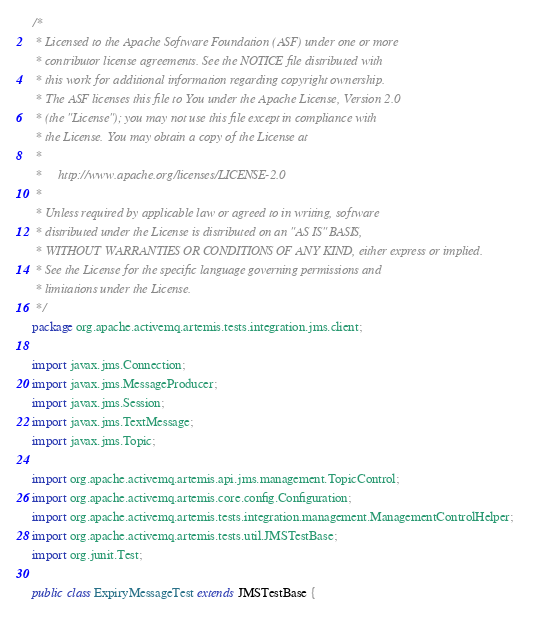Convert code to text. <code><loc_0><loc_0><loc_500><loc_500><_Java_>/*
 * Licensed to the Apache Software Foundation (ASF) under one or more
 * contributor license agreements. See the NOTICE file distributed with
 * this work for additional information regarding copyright ownership.
 * The ASF licenses this file to You under the Apache License, Version 2.0
 * (the "License"); you may not use this file except in compliance with
 * the License. You may obtain a copy of the License at
 *
 *     http://www.apache.org/licenses/LICENSE-2.0
 *
 * Unless required by applicable law or agreed to in writing, software
 * distributed under the License is distributed on an "AS IS" BASIS,
 * WITHOUT WARRANTIES OR CONDITIONS OF ANY KIND, either express or implied.
 * See the License for the specific language governing permissions and
 * limitations under the License.
 */
package org.apache.activemq.artemis.tests.integration.jms.client;

import javax.jms.Connection;
import javax.jms.MessageProducer;
import javax.jms.Session;
import javax.jms.TextMessage;
import javax.jms.Topic;

import org.apache.activemq.artemis.api.jms.management.TopicControl;
import org.apache.activemq.artemis.core.config.Configuration;
import org.apache.activemq.artemis.tests.integration.management.ManagementControlHelper;
import org.apache.activemq.artemis.tests.util.JMSTestBase;
import org.junit.Test;

public class ExpiryMessageTest extends JMSTestBase {</code> 